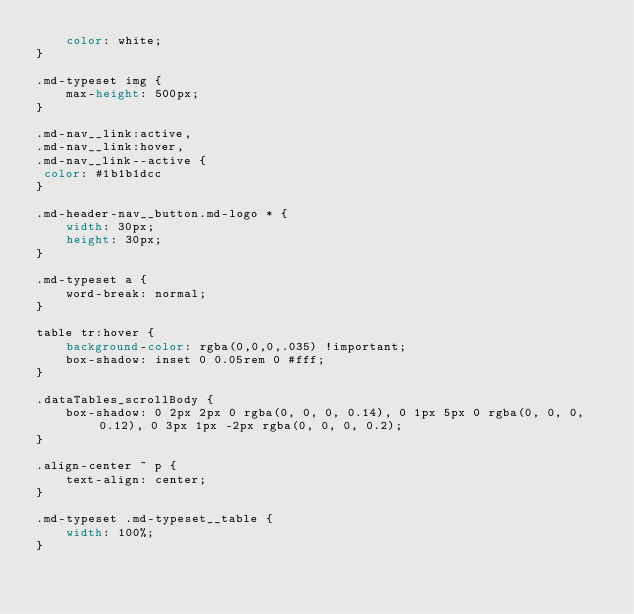Convert code to text. <code><loc_0><loc_0><loc_500><loc_500><_CSS_>    color: white;
}

.md-typeset img {
    max-height: 500px;
}

.md-nav__link:active, 
.md-nav__link:hover, 
.md-nav__link--active {
 color: #1b1b1dcc
}

.md-header-nav__button.md-logo * {
    width: 30px;
    height: 30px;
}

.md-typeset a {
    word-break: normal;
}

table tr:hover {
    background-color: rgba(0,0,0,.035) !important;
    box-shadow: inset 0 0.05rem 0 #fff;
}

.dataTables_scrollBody {
    box-shadow: 0 2px 2px 0 rgba(0, 0, 0, 0.14), 0 1px 5px 0 rgba(0, 0, 0, 0.12), 0 3px 1px -2px rgba(0, 0, 0, 0.2);
}

.align-center ~ p {
    text-align: center;
}

.md-typeset .md-typeset__table {
    width: 100%;
}</code> 